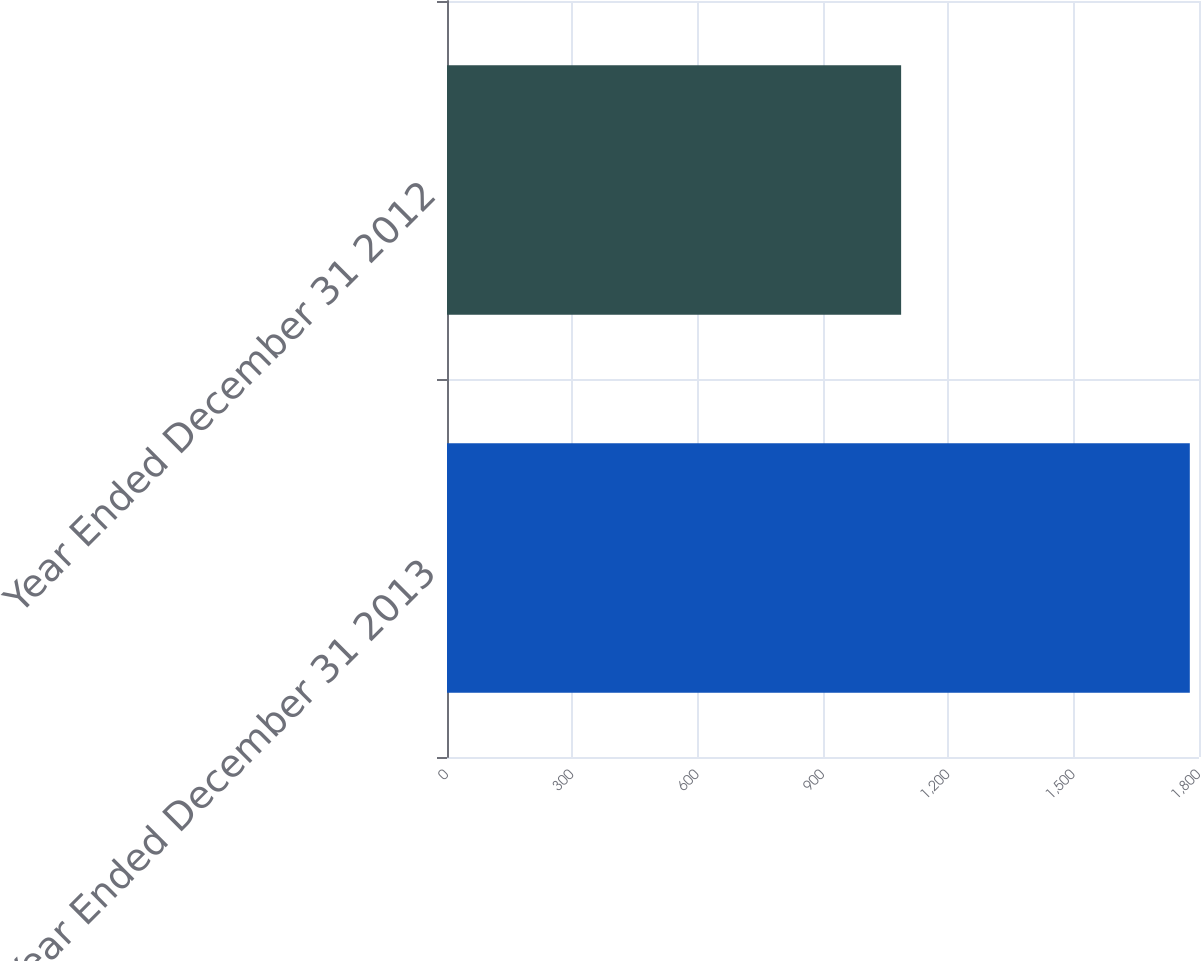<chart> <loc_0><loc_0><loc_500><loc_500><bar_chart><fcel>Year Ended December 31 2013<fcel>Year Ended December 31 2012<nl><fcel>1778<fcel>1087<nl></chart> 